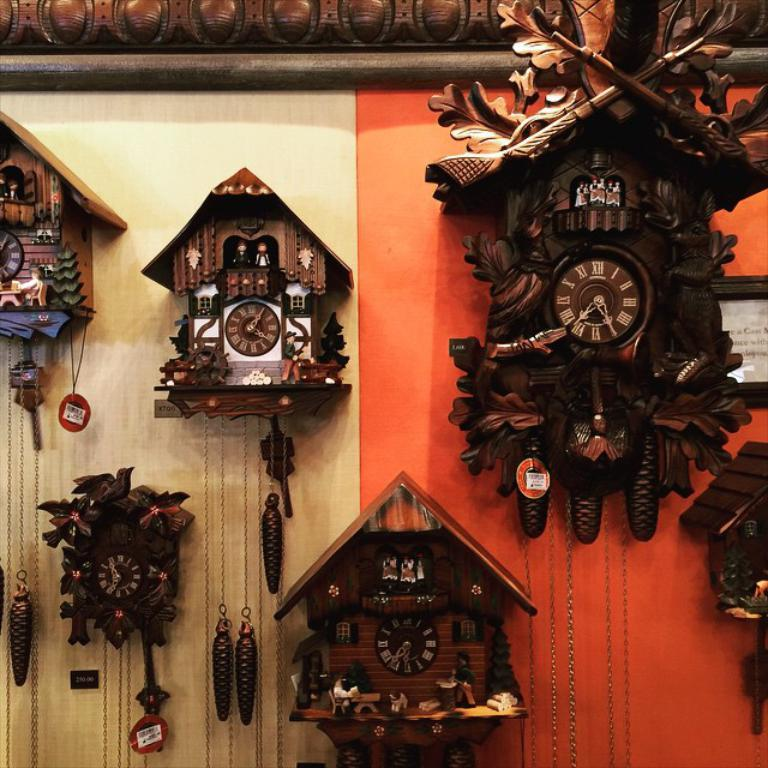Provide a one-sentence caption for the provided image. A collection of cuckoo clocks, of which the top right one says that it is 7:30. 